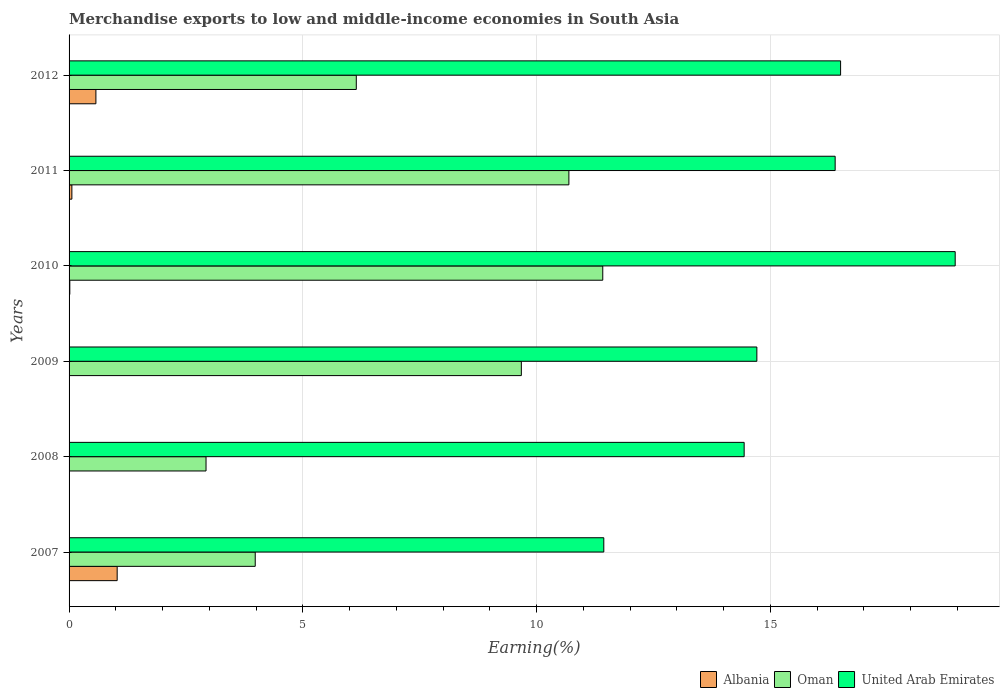Are the number of bars on each tick of the Y-axis equal?
Give a very brief answer. Yes. How many bars are there on the 5th tick from the top?
Your response must be concise. 3. What is the label of the 1st group of bars from the top?
Your answer should be very brief. 2012. What is the percentage of amount earned from merchandise exports in Albania in 2011?
Give a very brief answer. 0.06. Across all years, what is the maximum percentage of amount earned from merchandise exports in United Arab Emirates?
Offer a terse response. 18.95. Across all years, what is the minimum percentage of amount earned from merchandise exports in Albania?
Your answer should be very brief. 0. What is the total percentage of amount earned from merchandise exports in United Arab Emirates in the graph?
Ensure brevity in your answer.  92.43. What is the difference between the percentage of amount earned from merchandise exports in United Arab Emirates in 2009 and that in 2012?
Your response must be concise. -1.79. What is the difference between the percentage of amount earned from merchandise exports in Oman in 2010 and the percentage of amount earned from merchandise exports in Albania in 2012?
Keep it short and to the point. 10.84. What is the average percentage of amount earned from merchandise exports in Oman per year?
Give a very brief answer. 7.47. In the year 2010, what is the difference between the percentage of amount earned from merchandise exports in United Arab Emirates and percentage of amount earned from merchandise exports in Oman?
Give a very brief answer. 7.54. In how many years, is the percentage of amount earned from merchandise exports in United Arab Emirates greater than 18 %?
Provide a short and direct response. 1. What is the ratio of the percentage of amount earned from merchandise exports in Albania in 2009 to that in 2011?
Provide a succinct answer. 0.01. Is the percentage of amount earned from merchandise exports in Albania in 2007 less than that in 2012?
Give a very brief answer. No. What is the difference between the highest and the second highest percentage of amount earned from merchandise exports in United Arab Emirates?
Offer a terse response. 2.45. What is the difference between the highest and the lowest percentage of amount earned from merchandise exports in United Arab Emirates?
Provide a short and direct response. 7.52. In how many years, is the percentage of amount earned from merchandise exports in United Arab Emirates greater than the average percentage of amount earned from merchandise exports in United Arab Emirates taken over all years?
Your answer should be very brief. 3. Is the sum of the percentage of amount earned from merchandise exports in United Arab Emirates in 2007 and 2009 greater than the maximum percentage of amount earned from merchandise exports in Albania across all years?
Your answer should be very brief. Yes. What does the 1st bar from the top in 2009 represents?
Your answer should be compact. United Arab Emirates. What does the 2nd bar from the bottom in 2012 represents?
Your answer should be very brief. Oman. How many bars are there?
Give a very brief answer. 18. How many years are there in the graph?
Ensure brevity in your answer.  6. What is the difference between two consecutive major ticks on the X-axis?
Your answer should be compact. 5. Does the graph contain any zero values?
Keep it short and to the point. No. How are the legend labels stacked?
Give a very brief answer. Horizontal. What is the title of the graph?
Ensure brevity in your answer.  Merchandise exports to low and middle-income economies in South Asia. What is the label or title of the X-axis?
Provide a short and direct response. Earning(%). What is the Earning(%) in Albania in 2007?
Your answer should be very brief. 1.03. What is the Earning(%) of Oman in 2007?
Offer a terse response. 3.98. What is the Earning(%) in United Arab Emirates in 2007?
Make the answer very short. 11.44. What is the Earning(%) in Albania in 2008?
Provide a succinct answer. 0.01. What is the Earning(%) in Oman in 2008?
Your response must be concise. 2.93. What is the Earning(%) in United Arab Emirates in 2008?
Provide a short and direct response. 14.44. What is the Earning(%) of Albania in 2009?
Provide a succinct answer. 0. What is the Earning(%) in Oman in 2009?
Your answer should be very brief. 9.67. What is the Earning(%) of United Arab Emirates in 2009?
Ensure brevity in your answer.  14.71. What is the Earning(%) in Albania in 2010?
Offer a very short reply. 0.02. What is the Earning(%) in Oman in 2010?
Your response must be concise. 11.42. What is the Earning(%) in United Arab Emirates in 2010?
Give a very brief answer. 18.95. What is the Earning(%) in Albania in 2011?
Provide a succinct answer. 0.06. What is the Earning(%) of Oman in 2011?
Make the answer very short. 10.69. What is the Earning(%) of United Arab Emirates in 2011?
Ensure brevity in your answer.  16.39. What is the Earning(%) of Albania in 2012?
Your answer should be compact. 0.57. What is the Earning(%) of Oman in 2012?
Offer a very short reply. 6.14. What is the Earning(%) in United Arab Emirates in 2012?
Make the answer very short. 16.5. Across all years, what is the maximum Earning(%) in Albania?
Ensure brevity in your answer.  1.03. Across all years, what is the maximum Earning(%) of Oman?
Offer a terse response. 11.42. Across all years, what is the maximum Earning(%) of United Arab Emirates?
Make the answer very short. 18.95. Across all years, what is the minimum Earning(%) of Albania?
Provide a short and direct response. 0. Across all years, what is the minimum Earning(%) of Oman?
Make the answer very short. 2.93. Across all years, what is the minimum Earning(%) of United Arab Emirates?
Keep it short and to the point. 11.44. What is the total Earning(%) in Albania in the graph?
Give a very brief answer. 1.69. What is the total Earning(%) of Oman in the graph?
Your answer should be very brief. 44.84. What is the total Earning(%) in United Arab Emirates in the graph?
Offer a terse response. 92.43. What is the difference between the Earning(%) of Albania in 2007 and that in 2008?
Provide a succinct answer. 1.02. What is the difference between the Earning(%) in Oman in 2007 and that in 2008?
Give a very brief answer. 1.05. What is the difference between the Earning(%) in United Arab Emirates in 2007 and that in 2008?
Provide a succinct answer. -3. What is the difference between the Earning(%) in Albania in 2007 and that in 2009?
Provide a short and direct response. 1.03. What is the difference between the Earning(%) of Oman in 2007 and that in 2009?
Offer a very short reply. -5.69. What is the difference between the Earning(%) of United Arab Emirates in 2007 and that in 2009?
Offer a terse response. -3.27. What is the difference between the Earning(%) of Albania in 2007 and that in 2010?
Provide a succinct answer. 1.01. What is the difference between the Earning(%) in Oman in 2007 and that in 2010?
Your answer should be very brief. -7.43. What is the difference between the Earning(%) of United Arab Emirates in 2007 and that in 2010?
Your answer should be compact. -7.52. What is the difference between the Earning(%) of Albania in 2007 and that in 2011?
Provide a short and direct response. 0.97. What is the difference between the Earning(%) in Oman in 2007 and that in 2011?
Provide a short and direct response. -6.71. What is the difference between the Earning(%) of United Arab Emirates in 2007 and that in 2011?
Give a very brief answer. -4.95. What is the difference between the Earning(%) in Albania in 2007 and that in 2012?
Provide a succinct answer. 0.46. What is the difference between the Earning(%) in Oman in 2007 and that in 2012?
Make the answer very short. -2.16. What is the difference between the Earning(%) of United Arab Emirates in 2007 and that in 2012?
Your response must be concise. -5.07. What is the difference between the Earning(%) in Albania in 2008 and that in 2009?
Ensure brevity in your answer.  0.01. What is the difference between the Earning(%) in Oman in 2008 and that in 2009?
Your response must be concise. -6.74. What is the difference between the Earning(%) of United Arab Emirates in 2008 and that in 2009?
Offer a very short reply. -0.27. What is the difference between the Earning(%) of Albania in 2008 and that in 2010?
Provide a succinct answer. -0.01. What is the difference between the Earning(%) of Oman in 2008 and that in 2010?
Keep it short and to the point. -8.49. What is the difference between the Earning(%) of United Arab Emirates in 2008 and that in 2010?
Provide a short and direct response. -4.51. What is the difference between the Earning(%) in Albania in 2008 and that in 2011?
Keep it short and to the point. -0.05. What is the difference between the Earning(%) in Oman in 2008 and that in 2011?
Your answer should be very brief. -7.76. What is the difference between the Earning(%) in United Arab Emirates in 2008 and that in 2011?
Your answer should be compact. -1.95. What is the difference between the Earning(%) of Albania in 2008 and that in 2012?
Provide a succinct answer. -0.57. What is the difference between the Earning(%) of Oman in 2008 and that in 2012?
Your response must be concise. -3.21. What is the difference between the Earning(%) of United Arab Emirates in 2008 and that in 2012?
Offer a terse response. -2.06. What is the difference between the Earning(%) of Albania in 2009 and that in 2010?
Ensure brevity in your answer.  -0.02. What is the difference between the Earning(%) of Oman in 2009 and that in 2010?
Your response must be concise. -1.74. What is the difference between the Earning(%) in United Arab Emirates in 2009 and that in 2010?
Provide a succinct answer. -4.24. What is the difference between the Earning(%) of Albania in 2009 and that in 2011?
Your answer should be compact. -0.06. What is the difference between the Earning(%) in Oman in 2009 and that in 2011?
Make the answer very short. -1.02. What is the difference between the Earning(%) in United Arab Emirates in 2009 and that in 2011?
Give a very brief answer. -1.67. What is the difference between the Earning(%) of Albania in 2009 and that in 2012?
Provide a succinct answer. -0.57. What is the difference between the Earning(%) in Oman in 2009 and that in 2012?
Ensure brevity in your answer.  3.53. What is the difference between the Earning(%) of United Arab Emirates in 2009 and that in 2012?
Offer a very short reply. -1.79. What is the difference between the Earning(%) in Albania in 2010 and that in 2011?
Your response must be concise. -0.04. What is the difference between the Earning(%) of Oman in 2010 and that in 2011?
Give a very brief answer. 0.72. What is the difference between the Earning(%) in United Arab Emirates in 2010 and that in 2011?
Your answer should be very brief. 2.57. What is the difference between the Earning(%) in Albania in 2010 and that in 2012?
Keep it short and to the point. -0.56. What is the difference between the Earning(%) of Oman in 2010 and that in 2012?
Keep it short and to the point. 5.27. What is the difference between the Earning(%) in United Arab Emirates in 2010 and that in 2012?
Your response must be concise. 2.45. What is the difference between the Earning(%) of Albania in 2011 and that in 2012?
Ensure brevity in your answer.  -0.51. What is the difference between the Earning(%) of Oman in 2011 and that in 2012?
Provide a succinct answer. 4.55. What is the difference between the Earning(%) of United Arab Emirates in 2011 and that in 2012?
Your response must be concise. -0.12. What is the difference between the Earning(%) in Albania in 2007 and the Earning(%) in Oman in 2008?
Your answer should be compact. -1.9. What is the difference between the Earning(%) of Albania in 2007 and the Earning(%) of United Arab Emirates in 2008?
Give a very brief answer. -13.41. What is the difference between the Earning(%) in Oman in 2007 and the Earning(%) in United Arab Emirates in 2008?
Your answer should be very brief. -10.46. What is the difference between the Earning(%) in Albania in 2007 and the Earning(%) in Oman in 2009?
Provide a succinct answer. -8.65. What is the difference between the Earning(%) of Albania in 2007 and the Earning(%) of United Arab Emirates in 2009?
Offer a terse response. -13.68. What is the difference between the Earning(%) in Oman in 2007 and the Earning(%) in United Arab Emirates in 2009?
Make the answer very short. -10.73. What is the difference between the Earning(%) of Albania in 2007 and the Earning(%) of Oman in 2010?
Give a very brief answer. -10.39. What is the difference between the Earning(%) in Albania in 2007 and the Earning(%) in United Arab Emirates in 2010?
Your answer should be compact. -17.93. What is the difference between the Earning(%) of Oman in 2007 and the Earning(%) of United Arab Emirates in 2010?
Your answer should be very brief. -14.97. What is the difference between the Earning(%) in Albania in 2007 and the Earning(%) in Oman in 2011?
Your answer should be compact. -9.66. What is the difference between the Earning(%) in Albania in 2007 and the Earning(%) in United Arab Emirates in 2011?
Give a very brief answer. -15.36. What is the difference between the Earning(%) in Oman in 2007 and the Earning(%) in United Arab Emirates in 2011?
Keep it short and to the point. -12.4. What is the difference between the Earning(%) of Albania in 2007 and the Earning(%) of Oman in 2012?
Your answer should be very brief. -5.11. What is the difference between the Earning(%) of Albania in 2007 and the Earning(%) of United Arab Emirates in 2012?
Provide a succinct answer. -15.47. What is the difference between the Earning(%) of Oman in 2007 and the Earning(%) of United Arab Emirates in 2012?
Give a very brief answer. -12.52. What is the difference between the Earning(%) in Albania in 2008 and the Earning(%) in Oman in 2009?
Offer a very short reply. -9.67. What is the difference between the Earning(%) in Albania in 2008 and the Earning(%) in United Arab Emirates in 2009?
Provide a short and direct response. -14.71. What is the difference between the Earning(%) in Oman in 2008 and the Earning(%) in United Arab Emirates in 2009?
Give a very brief answer. -11.78. What is the difference between the Earning(%) in Albania in 2008 and the Earning(%) in Oman in 2010?
Provide a short and direct response. -11.41. What is the difference between the Earning(%) in Albania in 2008 and the Earning(%) in United Arab Emirates in 2010?
Offer a very short reply. -18.95. What is the difference between the Earning(%) of Oman in 2008 and the Earning(%) of United Arab Emirates in 2010?
Keep it short and to the point. -16.02. What is the difference between the Earning(%) of Albania in 2008 and the Earning(%) of Oman in 2011?
Ensure brevity in your answer.  -10.69. What is the difference between the Earning(%) in Albania in 2008 and the Earning(%) in United Arab Emirates in 2011?
Provide a succinct answer. -16.38. What is the difference between the Earning(%) in Oman in 2008 and the Earning(%) in United Arab Emirates in 2011?
Ensure brevity in your answer.  -13.46. What is the difference between the Earning(%) in Albania in 2008 and the Earning(%) in Oman in 2012?
Your answer should be compact. -6.14. What is the difference between the Earning(%) in Albania in 2008 and the Earning(%) in United Arab Emirates in 2012?
Ensure brevity in your answer.  -16.5. What is the difference between the Earning(%) of Oman in 2008 and the Earning(%) of United Arab Emirates in 2012?
Your answer should be very brief. -13.57. What is the difference between the Earning(%) of Albania in 2009 and the Earning(%) of Oman in 2010?
Ensure brevity in your answer.  -11.42. What is the difference between the Earning(%) in Albania in 2009 and the Earning(%) in United Arab Emirates in 2010?
Provide a short and direct response. -18.95. What is the difference between the Earning(%) in Oman in 2009 and the Earning(%) in United Arab Emirates in 2010?
Make the answer very short. -9.28. What is the difference between the Earning(%) in Albania in 2009 and the Earning(%) in Oman in 2011?
Ensure brevity in your answer.  -10.69. What is the difference between the Earning(%) of Albania in 2009 and the Earning(%) of United Arab Emirates in 2011?
Provide a short and direct response. -16.39. What is the difference between the Earning(%) of Oman in 2009 and the Earning(%) of United Arab Emirates in 2011?
Give a very brief answer. -6.71. What is the difference between the Earning(%) in Albania in 2009 and the Earning(%) in Oman in 2012?
Provide a succinct answer. -6.14. What is the difference between the Earning(%) of Albania in 2009 and the Earning(%) of United Arab Emirates in 2012?
Your response must be concise. -16.5. What is the difference between the Earning(%) of Oman in 2009 and the Earning(%) of United Arab Emirates in 2012?
Your answer should be very brief. -6.83. What is the difference between the Earning(%) of Albania in 2010 and the Earning(%) of Oman in 2011?
Offer a very short reply. -10.68. What is the difference between the Earning(%) in Albania in 2010 and the Earning(%) in United Arab Emirates in 2011?
Make the answer very short. -16.37. What is the difference between the Earning(%) in Oman in 2010 and the Earning(%) in United Arab Emirates in 2011?
Your answer should be compact. -4.97. What is the difference between the Earning(%) of Albania in 2010 and the Earning(%) of Oman in 2012?
Ensure brevity in your answer.  -6.13. What is the difference between the Earning(%) of Albania in 2010 and the Earning(%) of United Arab Emirates in 2012?
Offer a terse response. -16.49. What is the difference between the Earning(%) of Oman in 2010 and the Earning(%) of United Arab Emirates in 2012?
Offer a terse response. -5.09. What is the difference between the Earning(%) of Albania in 2011 and the Earning(%) of Oman in 2012?
Your answer should be compact. -6.08. What is the difference between the Earning(%) of Albania in 2011 and the Earning(%) of United Arab Emirates in 2012?
Make the answer very short. -16.44. What is the difference between the Earning(%) of Oman in 2011 and the Earning(%) of United Arab Emirates in 2012?
Ensure brevity in your answer.  -5.81. What is the average Earning(%) in Albania per year?
Ensure brevity in your answer.  0.28. What is the average Earning(%) of Oman per year?
Your answer should be very brief. 7.47. What is the average Earning(%) of United Arab Emirates per year?
Provide a succinct answer. 15.41. In the year 2007, what is the difference between the Earning(%) in Albania and Earning(%) in Oman?
Ensure brevity in your answer.  -2.95. In the year 2007, what is the difference between the Earning(%) of Albania and Earning(%) of United Arab Emirates?
Your answer should be compact. -10.41. In the year 2007, what is the difference between the Earning(%) in Oman and Earning(%) in United Arab Emirates?
Your answer should be compact. -7.46. In the year 2008, what is the difference between the Earning(%) in Albania and Earning(%) in Oman?
Offer a very short reply. -2.92. In the year 2008, what is the difference between the Earning(%) in Albania and Earning(%) in United Arab Emirates?
Keep it short and to the point. -14.43. In the year 2008, what is the difference between the Earning(%) in Oman and Earning(%) in United Arab Emirates?
Give a very brief answer. -11.51. In the year 2009, what is the difference between the Earning(%) in Albania and Earning(%) in Oman?
Ensure brevity in your answer.  -9.67. In the year 2009, what is the difference between the Earning(%) of Albania and Earning(%) of United Arab Emirates?
Ensure brevity in your answer.  -14.71. In the year 2009, what is the difference between the Earning(%) in Oman and Earning(%) in United Arab Emirates?
Keep it short and to the point. -5.04. In the year 2010, what is the difference between the Earning(%) in Albania and Earning(%) in Oman?
Provide a succinct answer. -11.4. In the year 2010, what is the difference between the Earning(%) of Albania and Earning(%) of United Arab Emirates?
Make the answer very short. -18.94. In the year 2010, what is the difference between the Earning(%) in Oman and Earning(%) in United Arab Emirates?
Your response must be concise. -7.54. In the year 2011, what is the difference between the Earning(%) of Albania and Earning(%) of Oman?
Offer a very short reply. -10.63. In the year 2011, what is the difference between the Earning(%) in Albania and Earning(%) in United Arab Emirates?
Provide a succinct answer. -16.33. In the year 2011, what is the difference between the Earning(%) in Oman and Earning(%) in United Arab Emirates?
Ensure brevity in your answer.  -5.7. In the year 2012, what is the difference between the Earning(%) in Albania and Earning(%) in Oman?
Make the answer very short. -5.57. In the year 2012, what is the difference between the Earning(%) in Albania and Earning(%) in United Arab Emirates?
Make the answer very short. -15.93. In the year 2012, what is the difference between the Earning(%) of Oman and Earning(%) of United Arab Emirates?
Ensure brevity in your answer.  -10.36. What is the ratio of the Earning(%) of Albania in 2007 to that in 2008?
Your response must be concise. 173.61. What is the ratio of the Earning(%) of Oman in 2007 to that in 2008?
Offer a terse response. 1.36. What is the ratio of the Earning(%) of United Arab Emirates in 2007 to that in 2008?
Provide a succinct answer. 0.79. What is the ratio of the Earning(%) in Albania in 2007 to that in 2009?
Offer a terse response. 1872.91. What is the ratio of the Earning(%) of Oman in 2007 to that in 2009?
Your answer should be compact. 0.41. What is the ratio of the Earning(%) of United Arab Emirates in 2007 to that in 2009?
Your answer should be very brief. 0.78. What is the ratio of the Earning(%) in Albania in 2007 to that in 2010?
Provide a succinct answer. 64.54. What is the ratio of the Earning(%) in Oman in 2007 to that in 2010?
Your answer should be very brief. 0.35. What is the ratio of the Earning(%) in United Arab Emirates in 2007 to that in 2010?
Your answer should be compact. 0.6. What is the ratio of the Earning(%) in Albania in 2007 to that in 2011?
Ensure brevity in your answer.  17.18. What is the ratio of the Earning(%) in Oman in 2007 to that in 2011?
Ensure brevity in your answer.  0.37. What is the ratio of the Earning(%) of United Arab Emirates in 2007 to that in 2011?
Offer a very short reply. 0.7. What is the ratio of the Earning(%) in Albania in 2007 to that in 2012?
Your answer should be compact. 1.79. What is the ratio of the Earning(%) in Oman in 2007 to that in 2012?
Your answer should be compact. 0.65. What is the ratio of the Earning(%) in United Arab Emirates in 2007 to that in 2012?
Ensure brevity in your answer.  0.69. What is the ratio of the Earning(%) in Albania in 2008 to that in 2009?
Make the answer very short. 10.79. What is the ratio of the Earning(%) of Oman in 2008 to that in 2009?
Give a very brief answer. 0.3. What is the ratio of the Earning(%) in United Arab Emirates in 2008 to that in 2009?
Ensure brevity in your answer.  0.98. What is the ratio of the Earning(%) of Albania in 2008 to that in 2010?
Your answer should be compact. 0.37. What is the ratio of the Earning(%) in Oman in 2008 to that in 2010?
Ensure brevity in your answer.  0.26. What is the ratio of the Earning(%) of United Arab Emirates in 2008 to that in 2010?
Provide a short and direct response. 0.76. What is the ratio of the Earning(%) of Albania in 2008 to that in 2011?
Offer a terse response. 0.1. What is the ratio of the Earning(%) in Oman in 2008 to that in 2011?
Offer a very short reply. 0.27. What is the ratio of the Earning(%) of United Arab Emirates in 2008 to that in 2011?
Give a very brief answer. 0.88. What is the ratio of the Earning(%) of Albania in 2008 to that in 2012?
Your answer should be very brief. 0.01. What is the ratio of the Earning(%) of Oman in 2008 to that in 2012?
Your answer should be compact. 0.48. What is the ratio of the Earning(%) in United Arab Emirates in 2008 to that in 2012?
Your answer should be compact. 0.88. What is the ratio of the Earning(%) in Albania in 2009 to that in 2010?
Your response must be concise. 0.03. What is the ratio of the Earning(%) in Oman in 2009 to that in 2010?
Your answer should be very brief. 0.85. What is the ratio of the Earning(%) of United Arab Emirates in 2009 to that in 2010?
Give a very brief answer. 0.78. What is the ratio of the Earning(%) of Albania in 2009 to that in 2011?
Make the answer very short. 0.01. What is the ratio of the Earning(%) of Oman in 2009 to that in 2011?
Your response must be concise. 0.9. What is the ratio of the Earning(%) of United Arab Emirates in 2009 to that in 2011?
Provide a short and direct response. 0.9. What is the ratio of the Earning(%) of Oman in 2009 to that in 2012?
Your response must be concise. 1.57. What is the ratio of the Earning(%) in United Arab Emirates in 2009 to that in 2012?
Offer a terse response. 0.89. What is the ratio of the Earning(%) in Albania in 2010 to that in 2011?
Your answer should be compact. 0.27. What is the ratio of the Earning(%) in Oman in 2010 to that in 2011?
Offer a very short reply. 1.07. What is the ratio of the Earning(%) of United Arab Emirates in 2010 to that in 2011?
Make the answer very short. 1.16. What is the ratio of the Earning(%) in Albania in 2010 to that in 2012?
Offer a very short reply. 0.03. What is the ratio of the Earning(%) in Oman in 2010 to that in 2012?
Provide a short and direct response. 1.86. What is the ratio of the Earning(%) in United Arab Emirates in 2010 to that in 2012?
Your response must be concise. 1.15. What is the ratio of the Earning(%) of Albania in 2011 to that in 2012?
Give a very brief answer. 0.1. What is the ratio of the Earning(%) in Oman in 2011 to that in 2012?
Keep it short and to the point. 1.74. What is the difference between the highest and the second highest Earning(%) in Albania?
Make the answer very short. 0.46. What is the difference between the highest and the second highest Earning(%) of Oman?
Offer a terse response. 0.72. What is the difference between the highest and the second highest Earning(%) in United Arab Emirates?
Offer a very short reply. 2.45. What is the difference between the highest and the lowest Earning(%) in Albania?
Give a very brief answer. 1.03. What is the difference between the highest and the lowest Earning(%) of Oman?
Provide a short and direct response. 8.49. What is the difference between the highest and the lowest Earning(%) in United Arab Emirates?
Your answer should be compact. 7.52. 